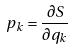<formula> <loc_0><loc_0><loc_500><loc_500>p _ { k } = \frac { \partial S } { \partial q _ { k } }</formula> 